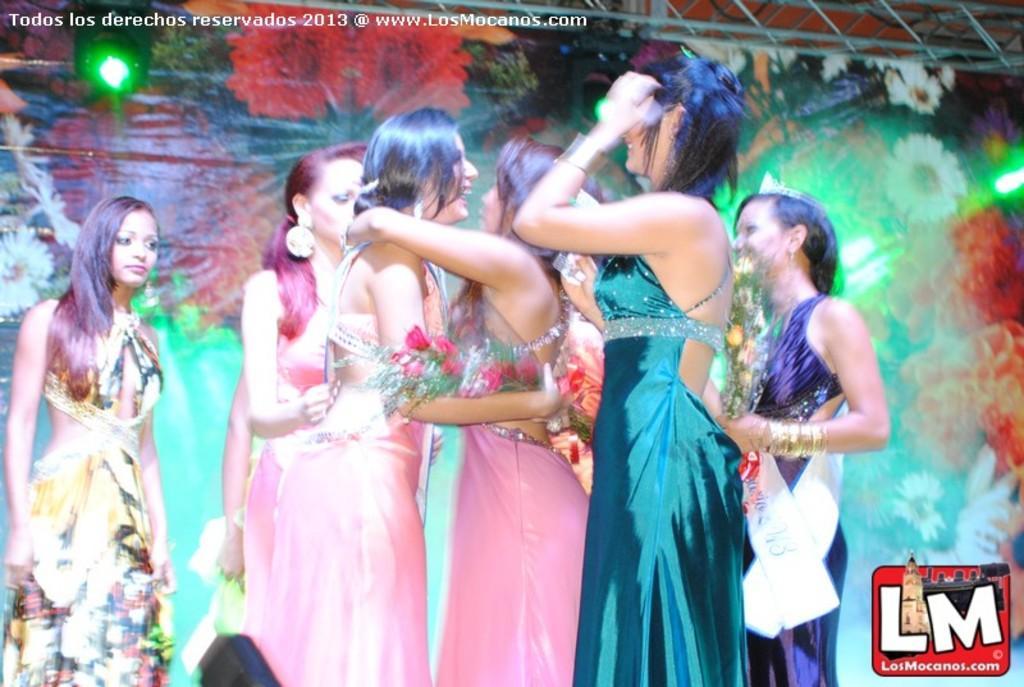Can you describe this image briefly? In this image we can see few ladies. One lady is holding a flower bouquet. In the back we can see light. Also there are watermarks in the image. At the top we can see stand with rods. 